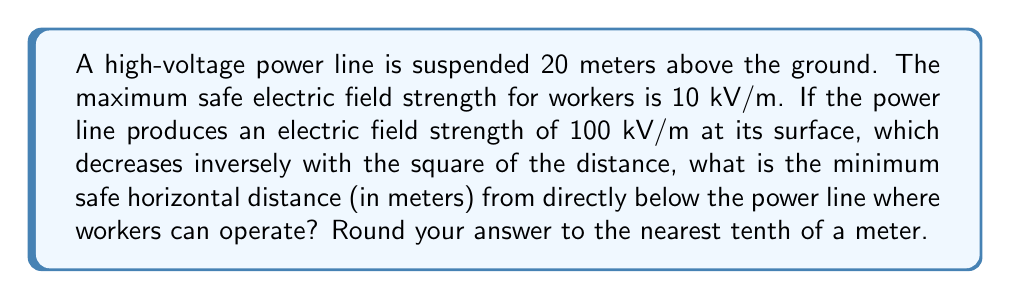Solve this math problem. Let's approach this step-by-step:

1) Let $x$ be the horizontal distance from directly below the power line, and $y$ be the vertical distance (20 m).

2) The total distance $d$ from the power line to the safe working point is:

   $$d = \sqrt{x^2 + y^2}$$

3) The electric field strength $E$ at distance $d$ is given by:

   $$E = \frac{100}{d^2} \text{ kV/m}$$

4) At the safe distance, $E = 10 \text{ kV/m}$. So we can write:

   $$10 = \frac{100}{d^2}$$

5) Solving for $d$:

   $$d^2 = \frac{100}{10} = 10$$
   $$d = \sqrt{10} \approx 3.16 \text{ m}$$

6) Now we can use the Pythagorean theorem:

   $$x^2 + 20^2 = d^2$$
   $$x^2 + 400 = 10$$
   $$x^2 = -390$$
   $$x = \sqrt{-390}$$

7) Since we can't have a negative distance under a square root, there is no real solution. This means workers cannot be directly under the power line at any distance and still be safe.

8) To find the minimum safe horizontal distance, we need to solve:

   $$x^2 + 20^2 = (\sqrt{10})^2$$
   $$x^2 = 10 - 400 = -390$$
   $$x = \sqrt{390} \approx 19.7 \text{ m}$$

9) Rounding to the nearest tenth:

   $$x \approx 19.7 \text{ m}$$

[asy]
import geometry;

unitsize(10);
draw((0,0)--(4,0), arrow=Arrow(TeXHead));
draw((0,0)--(0,2.5), arrow=Arrow(TeXHead));
draw((0,2)--(4,2));
draw((3.94,0)--(3.94,2), dashed);
dot((0,2));
dot((3.94,0));

label("Ground", (2,-.2));
label("20 m", (-.2,1));
label("Power line", (4.2,2));
label("x", (2,-.4));
label("Safe working point", (3.94,-.2));
[/asy]
Answer: 19.7 m 